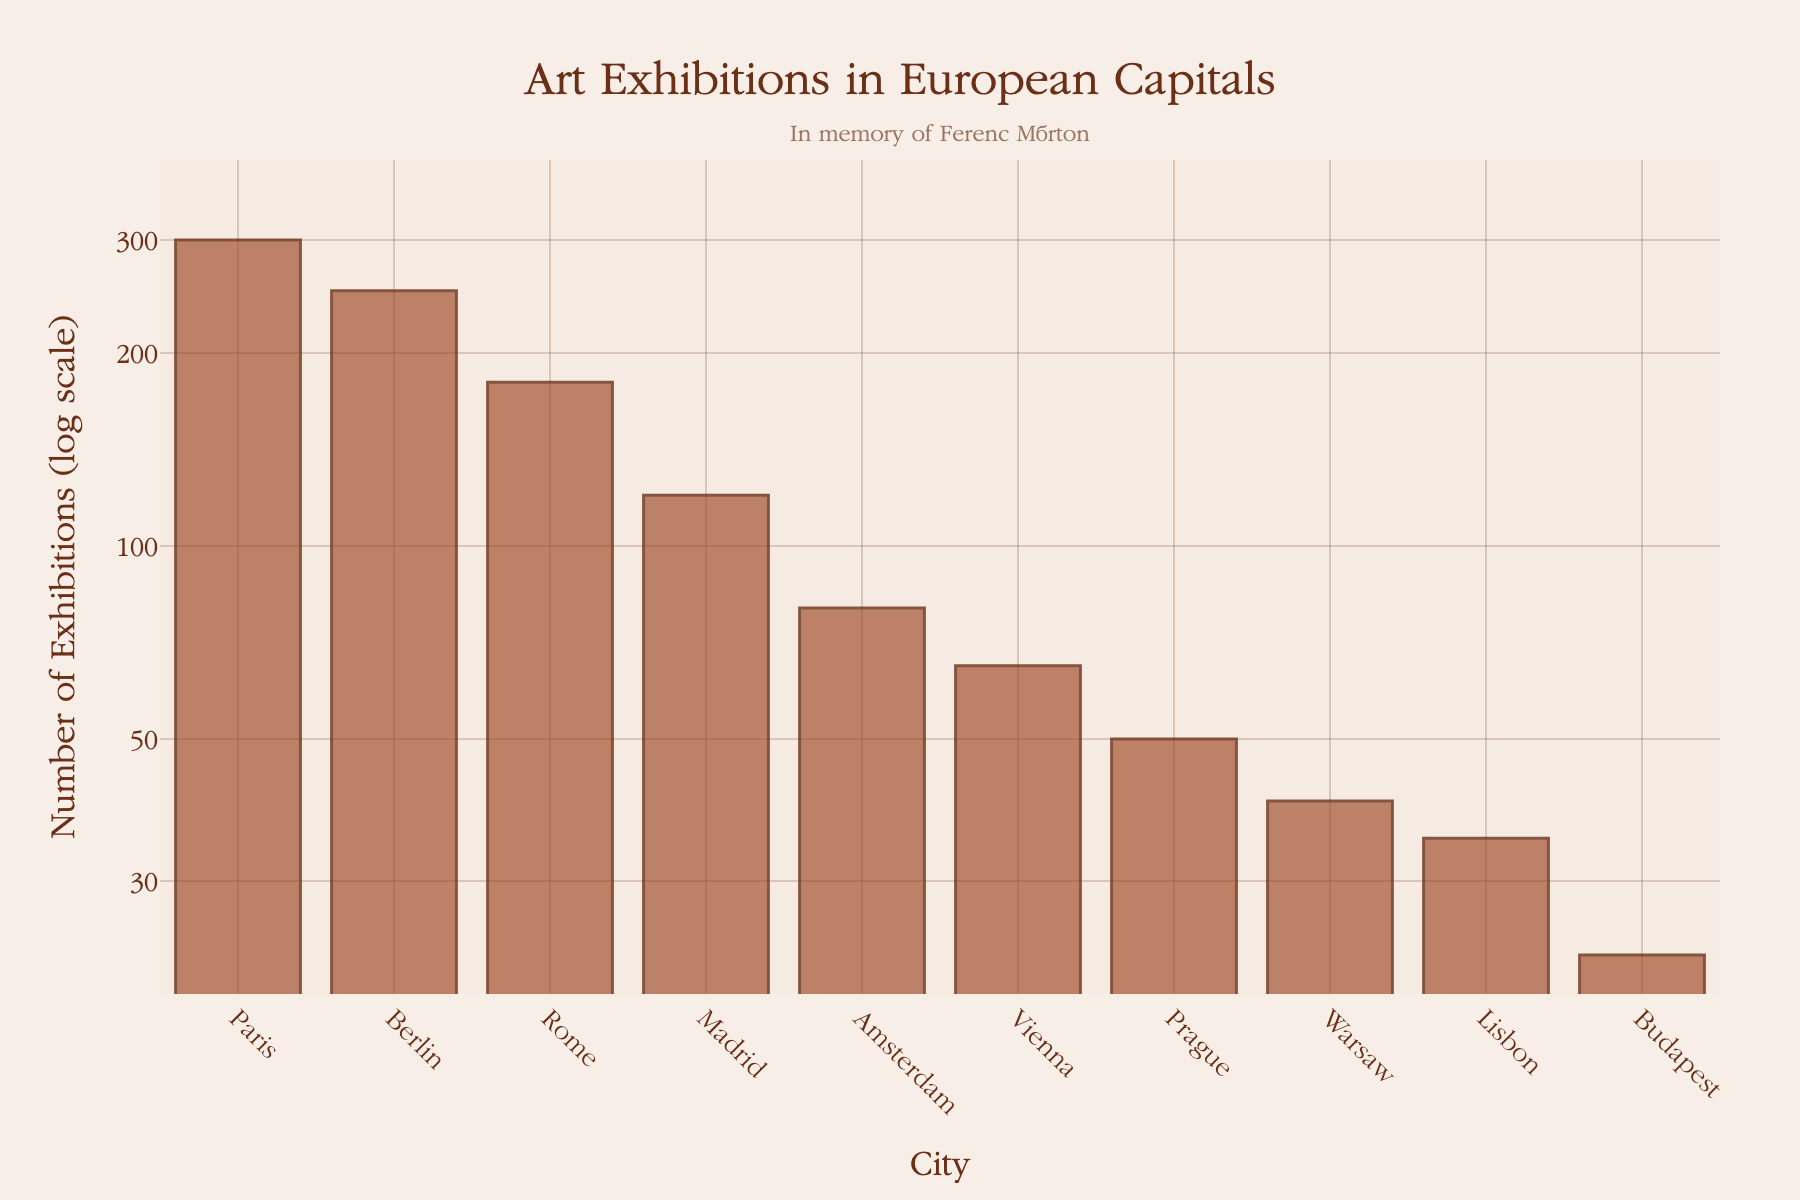What is the title of the plot? The title is displayed at the top center of the plot in a large, decorative font.
Answer: Art Exhibitions in European Capitals Which city has the highest number of art exhibitions? Look for the tallest bar in the chart, representing the city with the most exhibitions. The city name is on the x-axis and the bar height indicates 300 exhibitions.
Answer: Paris How many cities have less than 50 exhibitions? Identify the bars that correspond to fewer than 50 exhibitions and count them. The y-axis helps determine the log-transformed values.
Answer: 3 What is the color of the bars representing the frequency of art exhibitions? The bars' colors are described in the plot creation details and observed in the warm brown shading with darker outlines.
Answer: Warm brown Which cities have more exhibitions: Rome or Amsterdam? Compare the heights of the bars for Rome and Amsterdam. Rome has a higher bar than Amsterdam, indicating it has more exhibitions.
Answer: Rome What is the range of the y-axis in log scale? Look at the y-axis values from the bottom to the top of the plot. The range is from approximately 20 to 400.
Answer: 20 to 400 Which two cities have the closest number of exhibitions? By comparing the heights of adjacent bars, especially in the middle range, Vienna and Prague seem closest.
Answer: Vienna and Prague How many times more exhibitions does Paris have compared to Budapest? Paris exhibitions are 300 and Budapest exhibitions are 23. Divide 300 by 23 to find the ratio.
Answer: About 13 times Which city has the third highest number of exhibitions? Identify and count down from the tallest bar to find the third tallest. The third highest bar represents Berlin.
Answer: Berlin What is the distinction made in the annotation on the plot? There is a personal note in the plot's top center, dedicated to someone.
Answer: In memory of Ferenc Márton 